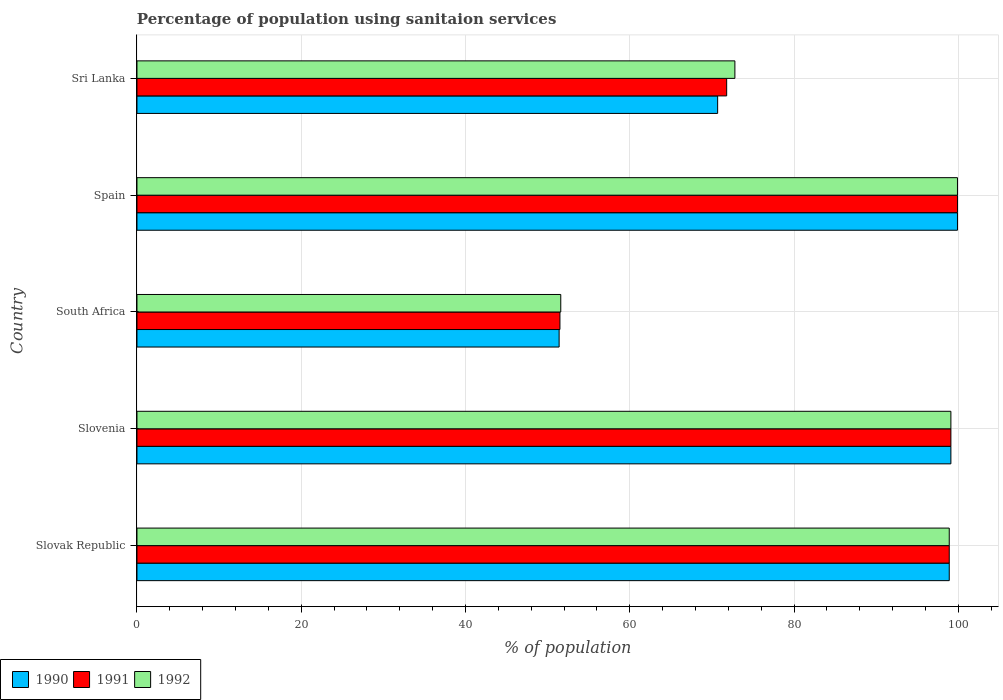How many groups of bars are there?
Offer a terse response. 5. Are the number of bars per tick equal to the number of legend labels?
Make the answer very short. Yes. Are the number of bars on each tick of the Y-axis equal?
Make the answer very short. Yes. What is the label of the 2nd group of bars from the top?
Ensure brevity in your answer.  Spain. What is the percentage of population using sanitaion services in 1990 in Slovenia?
Your answer should be very brief. 99.1. Across all countries, what is the maximum percentage of population using sanitaion services in 1990?
Give a very brief answer. 99.9. Across all countries, what is the minimum percentage of population using sanitaion services in 1992?
Provide a succinct answer. 51.6. In which country was the percentage of population using sanitaion services in 1990 minimum?
Make the answer very short. South Africa. What is the total percentage of population using sanitaion services in 1990 in the graph?
Keep it short and to the point. 420. What is the difference between the percentage of population using sanitaion services in 1991 in South Africa and that in Spain?
Your answer should be very brief. -48.4. What is the difference between the percentage of population using sanitaion services in 1990 in Spain and the percentage of population using sanitaion services in 1991 in Slovak Republic?
Your answer should be very brief. 1. What is the average percentage of population using sanitaion services in 1991 per country?
Your answer should be compact. 84.24. What is the difference between the percentage of population using sanitaion services in 1990 and percentage of population using sanitaion services in 1991 in Sri Lanka?
Offer a terse response. -1.1. What is the ratio of the percentage of population using sanitaion services in 1991 in Slovenia to that in Sri Lanka?
Keep it short and to the point. 1.38. What is the difference between the highest and the second highest percentage of population using sanitaion services in 1992?
Your answer should be very brief. 0.8. What is the difference between the highest and the lowest percentage of population using sanitaion services in 1990?
Your response must be concise. 48.5. In how many countries, is the percentage of population using sanitaion services in 1992 greater than the average percentage of population using sanitaion services in 1992 taken over all countries?
Offer a very short reply. 3. What does the 3rd bar from the top in Sri Lanka represents?
Provide a succinct answer. 1990. Is it the case that in every country, the sum of the percentage of population using sanitaion services in 1991 and percentage of population using sanitaion services in 1990 is greater than the percentage of population using sanitaion services in 1992?
Ensure brevity in your answer.  Yes. Does the graph contain any zero values?
Keep it short and to the point. No. Where does the legend appear in the graph?
Ensure brevity in your answer.  Bottom left. How many legend labels are there?
Keep it short and to the point. 3. How are the legend labels stacked?
Ensure brevity in your answer.  Horizontal. What is the title of the graph?
Offer a terse response. Percentage of population using sanitaion services. Does "1987" appear as one of the legend labels in the graph?
Offer a terse response. No. What is the label or title of the X-axis?
Offer a terse response. % of population. What is the % of population of 1990 in Slovak Republic?
Your answer should be compact. 98.9. What is the % of population of 1991 in Slovak Republic?
Your response must be concise. 98.9. What is the % of population in 1992 in Slovak Republic?
Ensure brevity in your answer.  98.9. What is the % of population of 1990 in Slovenia?
Give a very brief answer. 99.1. What is the % of population of 1991 in Slovenia?
Provide a short and direct response. 99.1. What is the % of population of 1992 in Slovenia?
Provide a succinct answer. 99.1. What is the % of population of 1990 in South Africa?
Your answer should be very brief. 51.4. What is the % of population in 1991 in South Africa?
Give a very brief answer. 51.5. What is the % of population in 1992 in South Africa?
Provide a succinct answer. 51.6. What is the % of population of 1990 in Spain?
Your response must be concise. 99.9. What is the % of population in 1991 in Spain?
Keep it short and to the point. 99.9. What is the % of population in 1992 in Spain?
Give a very brief answer. 99.9. What is the % of population of 1990 in Sri Lanka?
Your response must be concise. 70.7. What is the % of population of 1991 in Sri Lanka?
Your answer should be compact. 71.8. What is the % of population in 1992 in Sri Lanka?
Offer a terse response. 72.8. Across all countries, what is the maximum % of population in 1990?
Your response must be concise. 99.9. Across all countries, what is the maximum % of population of 1991?
Your answer should be compact. 99.9. Across all countries, what is the maximum % of population of 1992?
Provide a short and direct response. 99.9. Across all countries, what is the minimum % of population in 1990?
Ensure brevity in your answer.  51.4. Across all countries, what is the minimum % of population of 1991?
Provide a succinct answer. 51.5. Across all countries, what is the minimum % of population in 1992?
Your answer should be very brief. 51.6. What is the total % of population in 1990 in the graph?
Your answer should be very brief. 420. What is the total % of population in 1991 in the graph?
Make the answer very short. 421.2. What is the total % of population in 1992 in the graph?
Make the answer very short. 422.3. What is the difference between the % of population in 1991 in Slovak Republic and that in Slovenia?
Provide a succinct answer. -0.2. What is the difference between the % of population in 1992 in Slovak Republic and that in Slovenia?
Keep it short and to the point. -0.2. What is the difference between the % of population in 1990 in Slovak Republic and that in South Africa?
Offer a very short reply. 47.5. What is the difference between the % of population of 1991 in Slovak Republic and that in South Africa?
Give a very brief answer. 47.4. What is the difference between the % of population in 1992 in Slovak Republic and that in South Africa?
Make the answer very short. 47.3. What is the difference between the % of population of 1990 in Slovak Republic and that in Spain?
Offer a terse response. -1. What is the difference between the % of population of 1991 in Slovak Republic and that in Spain?
Make the answer very short. -1. What is the difference between the % of population of 1992 in Slovak Republic and that in Spain?
Keep it short and to the point. -1. What is the difference between the % of population in 1990 in Slovak Republic and that in Sri Lanka?
Make the answer very short. 28.2. What is the difference between the % of population of 1991 in Slovak Republic and that in Sri Lanka?
Offer a very short reply. 27.1. What is the difference between the % of population of 1992 in Slovak Republic and that in Sri Lanka?
Offer a terse response. 26.1. What is the difference between the % of population of 1990 in Slovenia and that in South Africa?
Keep it short and to the point. 47.7. What is the difference between the % of population in 1991 in Slovenia and that in South Africa?
Your answer should be compact. 47.6. What is the difference between the % of population in 1992 in Slovenia and that in South Africa?
Provide a succinct answer. 47.5. What is the difference between the % of population in 1990 in Slovenia and that in Spain?
Your response must be concise. -0.8. What is the difference between the % of population of 1992 in Slovenia and that in Spain?
Your response must be concise. -0.8. What is the difference between the % of population in 1990 in Slovenia and that in Sri Lanka?
Offer a terse response. 28.4. What is the difference between the % of population in 1991 in Slovenia and that in Sri Lanka?
Keep it short and to the point. 27.3. What is the difference between the % of population of 1992 in Slovenia and that in Sri Lanka?
Your answer should be very brief. 26.3. What is the difference between the % of population of 1990 in South Africa and that in Spain?
Give a very brief answer. -48.5. What is the difference between the % of population of 1991 in South Africa and that in Spain?
Provide a short and direct response. -48.4. What is the difference between the % of population in 1992 in South Africa and that in Spain?
Offer a terse response. -48.3. What is the difference between the % of population of 1990 in South Africa and that in Sri Lanka?
Offer a terse response. -19.3. What is the difference between the % of population of 1991 in South Africa and that in Sri Lanka?
Your response must be concise. -20.3. What is the difference between the % of population of 1992 in South Africa and that in Sri Lanka?
Your answer should be compact. -21.2. What is the difference between the % of population of 1990 in Spain and that in Sri Lanka?
Your answer should be compact. 29.2. What is the difference between the % of population in 1991 in Spain and that in Sri Lanka?
Your answer should be very brief. 28.1. What is the difference between the % of population of 1992 in Spain and that in Sri Lanka?
Your answer should be very brief. 27.1. What is the difference between the % of population of 1990 in Slovak Republic and the % of population of 1992 in Slovenia?
Provide a short and direct response. -0.2. What is the difference between the % of population of 1991 in Slovak Republic and the % of population of 1992 in Slovenia?
Your answer should be compact. -0.2. What is the difference between the % of population of 1990 in Slovak Republic and the % of population of 1991 in South Africa?
Provide a short and direct response. 47.4. What is the difference between the % of population of 1990 in Slovak Republic and the % of population of 1992 in South Africa?
Your response must be concise. 47.3. What is the difference between the % of population of 1991 in Slovak Republic and the % of population of 1992 in South Africa?
Your answer should be compact. 47.3. What is the difference between the % of population of 1990 in Slovak Republic and the % of population of 1991 in Spain?
Offer a very short reply. -1. What is the difference between the % of population of 1990 in Slovak Republic and the % of population of 1992 in Spain?
Offer a terse response. -1. What is the difference between the % of population in 1991 in Slovak Republic and the % of population in 1992 in Spain?
Make the answer very short. -1. What is the difference between the % of population in 1990 in Slovak Republic and the % of population in 1991 in Sri Lanka?
Provide a short and direct response. 27.1. What is the difference between the % of population in 1990 in Slovak Republic and the % of population in 1992 in Sri Lanka?
Offer a terse response. 26.1. What is the difference between the % of population of 1991 in Slovak Republic and the % of population of 1992 in Sri Lanka?
Offer a very short reply. 26.1. What is the difference between the % of population in 1990 in Slovenia and the % of population in 1991 in South Africa?
Keep it short and to the point. 47.6. What is the difference between the % of population of 1990 in Slovenia and the % of population of 1992 in South Africa?
Your answer should be compact. 47.5. What is the difference between the % of population of 1991 in Slovenia and the % of population of 1992 in South Africa?
Ensure brevity in your answer.  47.5. What is the difference between the % of population of 1990 in Slovenia and the % of population of 1991 in Spain?
Provide a succinct answer. -0.8. What is the difference between the % of population of 1990 in Slovenia and the % of population of 1992 in Spain?
Your response must be concise. -0.8. What is the difference between the % of population of 1990 in Slovenia and the % of population of 1991 in Sri Lanka?
Offer a terse response. 27.3. What is the difference between the % of population of 1990 in Slovenia and the % of population of 1992 in Sri Lanka?
Make the answer very short. 26.3. What is the difference between the % of population in 1991 in Slovenia and the % of population in 1992 in Sri Lanka?
Provide a short and direct response. 26.3. What is the difference between the % of population in 1990 in South Africa and the % of population in 1991 in Spain?
Your answer should be compact. -48.5. What is the difference between the % of population in 1990 in South Africa and the % of population in 1992 in Spain?
Your response must be concise. -48.5. What is the difference between the % of population of 1991 in South Africa and the % of population of 1992 in Spain?
Your response must be concise. -48.4. What is the difference between the % of population of 1990 in South Africa and the % of population of 1991 in Sri Lanka?
Your answer should be compact. -20.4. What is the difference between the % of population of 1990 in South Africa and the % of population of 1992 in Sri Lanka?
Offer a terse response. -21.4. What is the difference between the % of population of 1991 in South Africa and the % of population of 1992 in Sri Lanka?
Ensure brevity in your answer.  -21.3. What is the difference between the % of population of 1990 in Spain and the % of population of 1991 in Sri Lanka?
Ensure brevity in your answer.  28.1. What is the difference between the % of population of 1990 in Spain and the % of population of 1992 in Sri Lanka?
Offer a very short reply. 27.1. What is the difference between the % of population of 1991 in Spain and the % of population of 1992 in Sri Lanka?
Give a very brief answer. 27.1. What is the average % of population in 1990 per country?
Offer a very short reply. 84. What is the average % of population in 1991 per country?
Provide a succinct answer. 84.24. What is the average % of population in 1992 per country?
Make the answer very short. 84.46. What is the difference between the % of population of 1990 and % of population of 1991 in Slovak Republic?
Offer a terse response. 0. What is the difference between the % of population of 1991 and % of population of 1992 in Slovak Republic?
Ensure brevity in your answer.  0. What is the difference between the % of population of 1990 and % of population of 1991 in Slovenia?
Make the answer very short. 0. What is the difference between the % of population of 1991 and % of population of 1992 in Slovenia?
Your answer should be very brief. 0. What is the difference between the % of population of 1990 and % of population of 1991 in South Africa?
Ensure brevity in your answer.  -0.1. What is the difference between the % of population in 1990 and % of population in 1992 in South Africa?
Your answer should be compact. -0.2. What is the difference between the % of population in 1991 and % of population in 1992 in South Africa?
Ensure brevity in your answer.  -0.1. What is the difference between the % of population of 1990 and % of population of 1991 in Spain?
Your answer should be very brief. 0. What is the difference between the % of population of 1990 and % of population of 1992 in Spain?
Ensure brevity in your answer.  0. What is the difference between the % of population of 1991 and % of population of 1992 in Sri Lanka?
Your answer should be compact. -1. What is the ratio of the % of population of 1992 in Slovak Republic to that in Slovenia?
Offer a terse response. 1. What is the ratio of the % of population of 1990 in Slovak Republic to that in South Africa?
Offer a terse response. 1.92. What is the ratio of the % of population in 1991 in Slovak Republic to that in South Africa?
Ensure brevity in your answer.  1.92. What is the ratio of the % of population of 1992 in Slovak Republic to that in South Africa?
Your response must be concise. 1.92. What is the ratio of the % of population of 1990 in Slovak Republic to that in Spain?
Provide a succinct answer. 0.99. What is the ratio of the % of population of 1990 in Slovak Republic to that in Sri Lanka?
Your answer should be very brief. 1.4. What is the ratio of the % of population in 1991 in Slovak Republic to that in Sri Lanka?
Give a very brief answer. 1.38. What is the ratio of the % of population of 1992 in Slovak Republic to that in Sri Lanka?
Make the answer very short. 1.36. What is the ratio of the % of population in 1990 in Slovenia to that in South Africa?
Offer a very short reply. 1.93. What is the ratio of the % of population of 1991 in Slovenia to that in South Africa?
Keep it short and to the point. 1.92. What is the ratio of the % of population of 1992 in Slovenia to that in South Africa?
Give a very brief answer. 1.92. What is the ratio of the % of population of 1990 in Slovenia to that in Sri Lanka?
Keep it short and to the point. 1.4. What is the ratio of the % of population of 1991 in Slovenia to that in Sri Lanka?
Offer a terse response. 1.38. What is the ratio of the % of population of 1992 in Slovenia to that in Sri Lanka?
Ensure brevity in your answer.  1.36. What is the ratio of the % of population in 1990 in South Africa to that in Spain?
Offer a very short reply. 0.51. What is the ratio of the % of population in 1991 in South Africa to that in Spain?
Provide a short and direct response. 0.52. What is the ratio of the % of population in 1992 in South Africa to that in Spain?
Your answer should be compact. 0.52. What is the ratio of the % of population in 1990 in South Africa to that in Sri Lanka?
Provide a short and direct response. 0.73. What is the ratio of the % of population in 1991 in South Africa to that in Sri Lanka?
Offer a very short reply. 0.72. What is the ratio of the % of population in 1992 in South Africa to that in Sri Lanka?
Provide a succinct answer. 0.71. What is the ratio of the % of population of 1990 in Spain to that in Sri Lanka?
Your answer should be compact. 1.41. What is the ratio of the % of population in 1991 in Spain to that in Sri Lanka?
Offer a very short reply. 1.39. What is the ratio of the % of population in 1992 in Spain to that in Sri Lanka?
Your answer should be very brief. 1.37. What is the difference between the highest and the second highest % of population of 1991?
Provide a succinct answer. 0.8. What is the difference between the highest and the lowest % of population of 1990?
Give a very brief answer. 48.5. What is the difference between the highest and the lowest % of population of 1991?
Ensure brevity in your answer.  48.4. What is the difference between the highest and the lowest % of population of 1992?
Your answer should be compact. 48.3. 